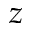Convert formula to latex. <formula><loc_0><loc_0><loc_500><loc_500>z</formula> 